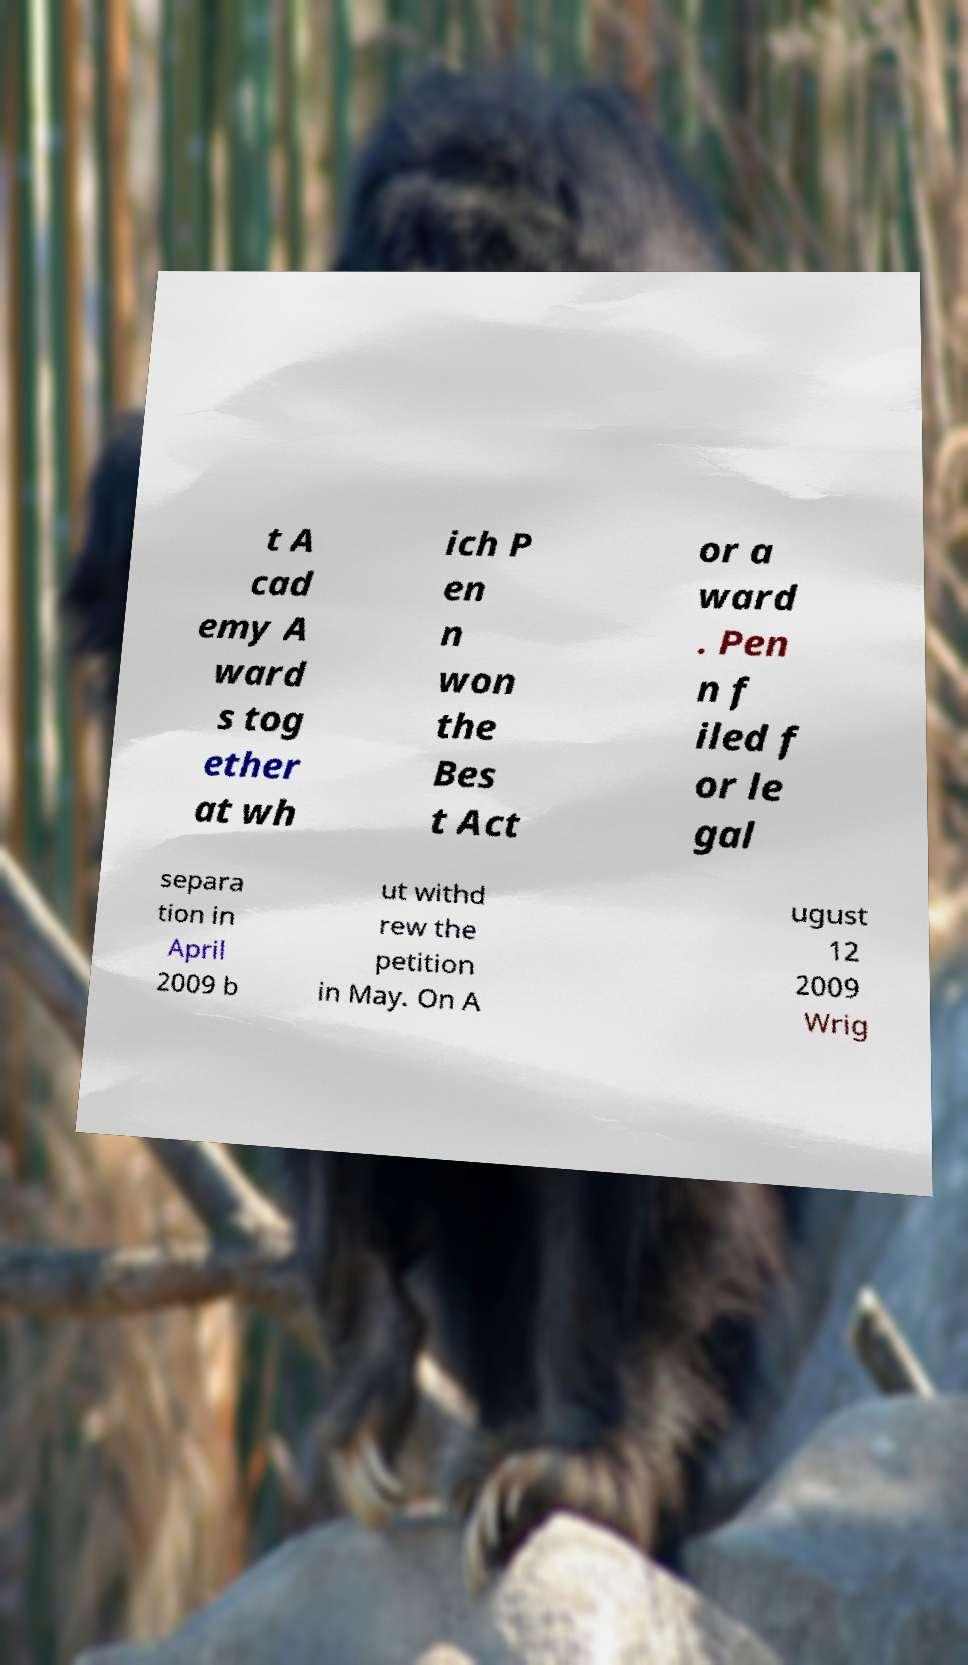Could you extract and type out the text from this image? t A cad emy A ward s tog ether at wh ich P en n won the Bes t Act or a ward . Pen n f iled f or le gal separa tion in April 2009 b ut withd rew the petition in May. On A ugust 12 2009 Wrig 